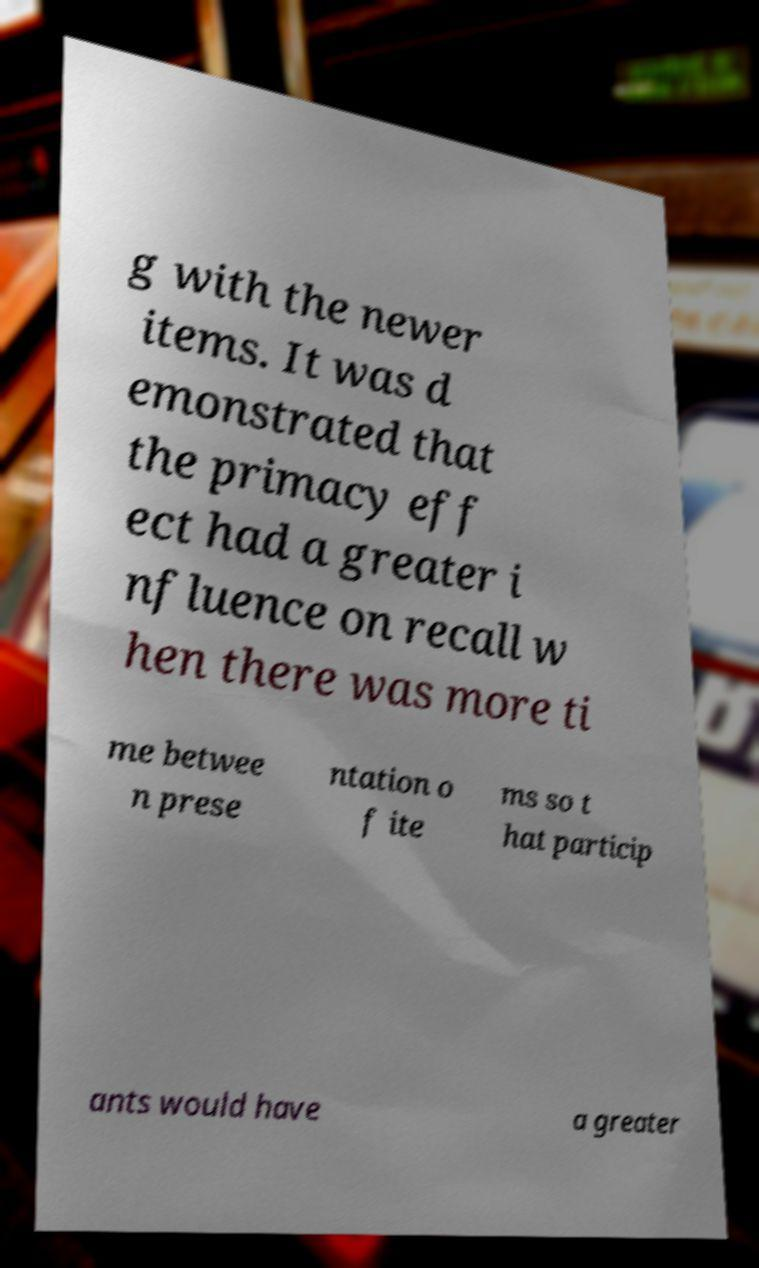Please identify and transcribe the text found in this image. g with the newer items. It was d emonstrated that the primacy eff ect had a greater i nfluence on recall w hen there was more ti me betwee n prese ntation o f ite ms so t hat particip ants would have a greater 